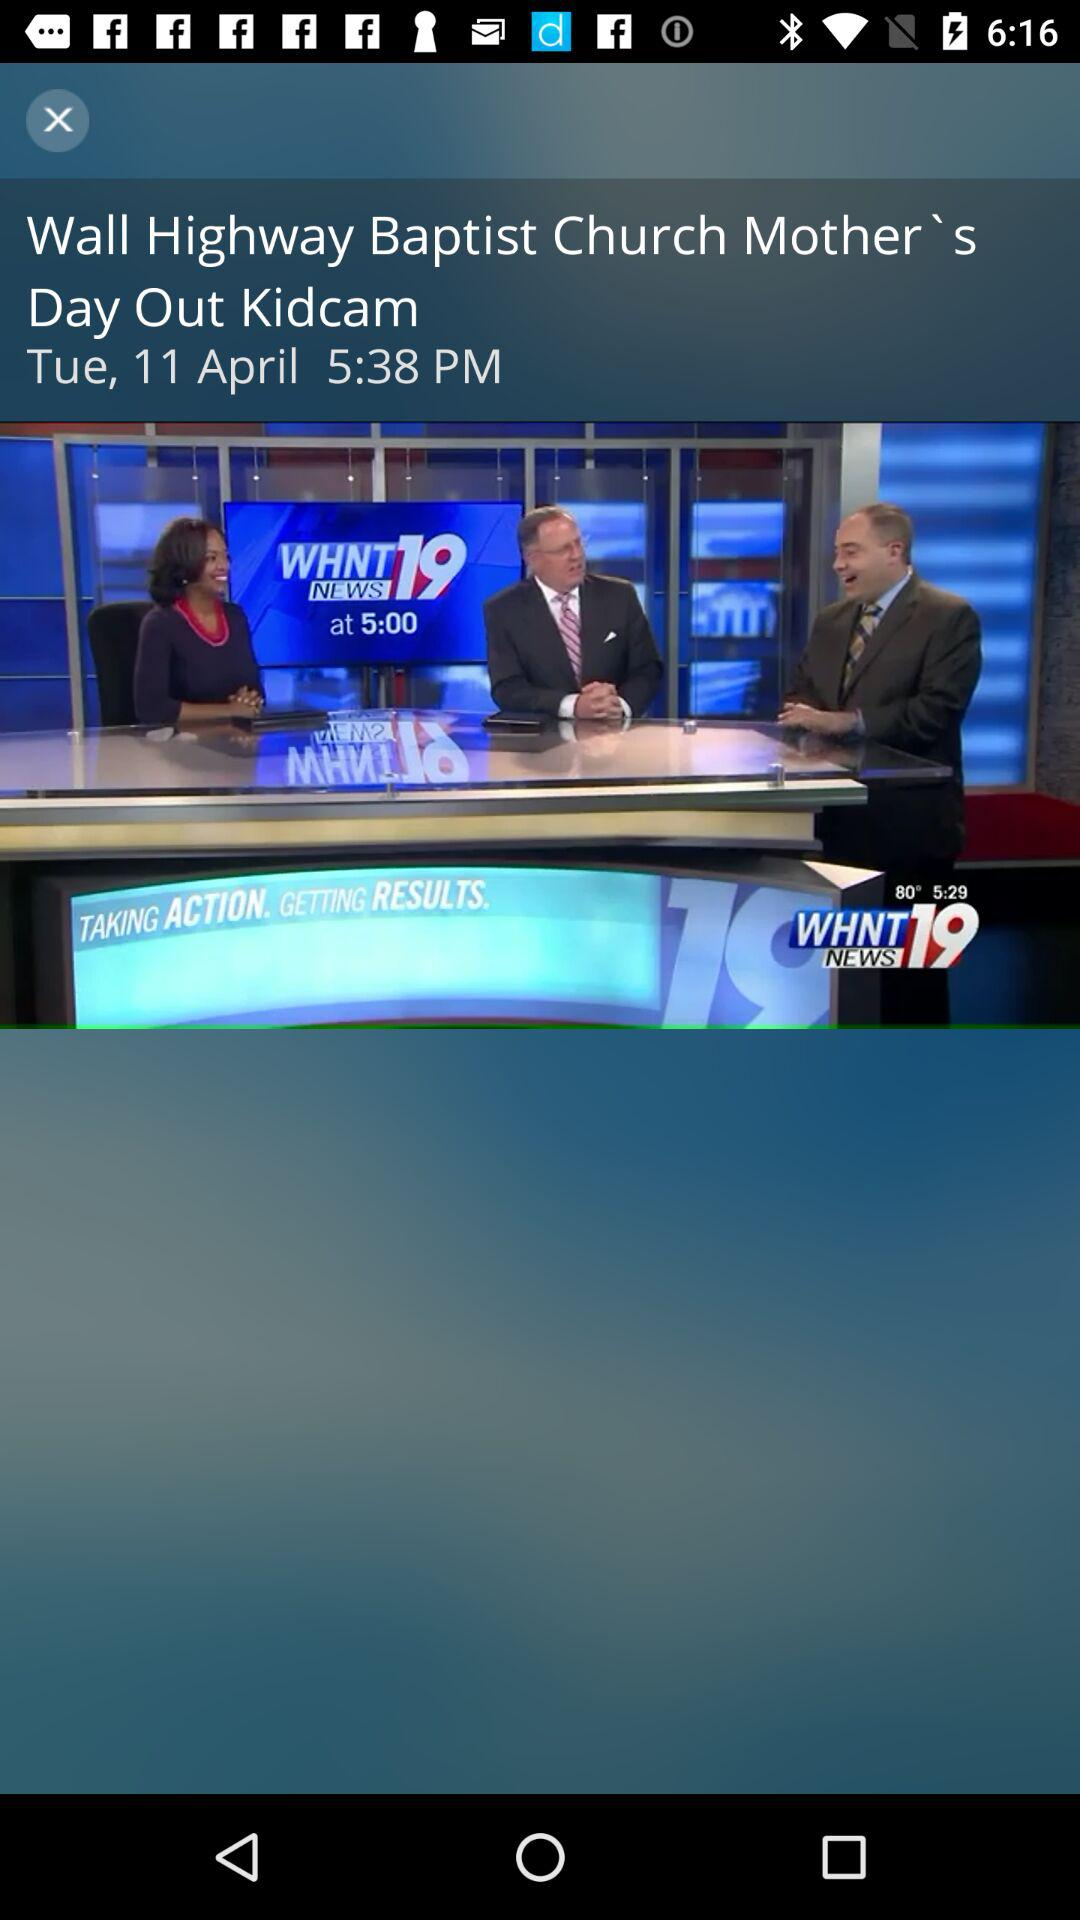What is the date and time shown on the screen? The date and time shown on the screen are Tuesday, April 11 and 5:38 PM respectively. 